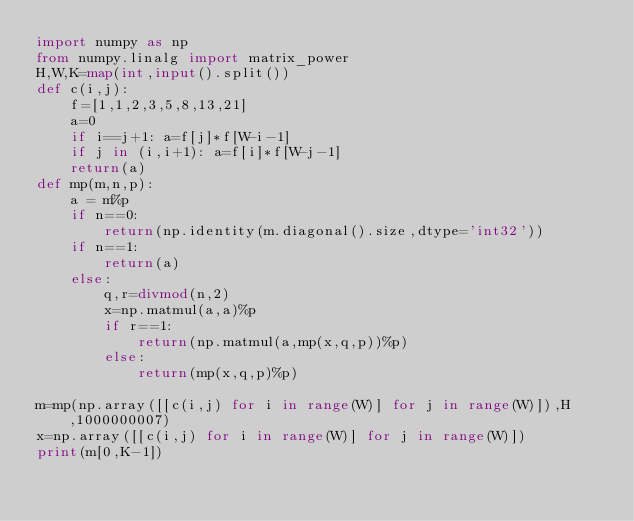Convert code to text. <code><loc_0><loc_0><loc_500><loc_500><_Python_>import numpy as np
from numpy.linalg import matrix_power
H,W,K=map(int,input().split())
def c(i,j):
    f=[1,1,2,3,5,8,13,21]
    a=0
    if i==j+1: a=f[j]*f[W-i-1]
    if j in (i,i+1): a=f[i]*f[W-j-1]
    return(a)
def mp(m,n,p):
    a = m%p
    if n==0:
        return(np.identity(m.diagonal().size,dtype='int32'))
    if n==1:
        return(a)
    else:
        q,r=divmod(n,2)
        x=np.matmul(a,a)%p
        if r==1:
            return(np.matmul(a,mp(x,q,p))%p)
        else:
            return(mp(x,q,p)%p)

m=mp(np.array([[c(i,j) for i in range(W)] for j in range(W)]),H,1000000007)
x=np.array([[c(i,j) for i in range(W)] for j in range(W)])
print(m[0,K-1])

          </code> 